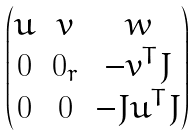Convert formula to latex. <formula><loc_0><loc_0><loc_500><loc_500>\begin{pmatrix} u & v & w \\ 0 & 0 _ { r } & - v ^ { T } J \\ 0 & 0 & - J u ^ { T } J \end{pmatrix}</formula> 